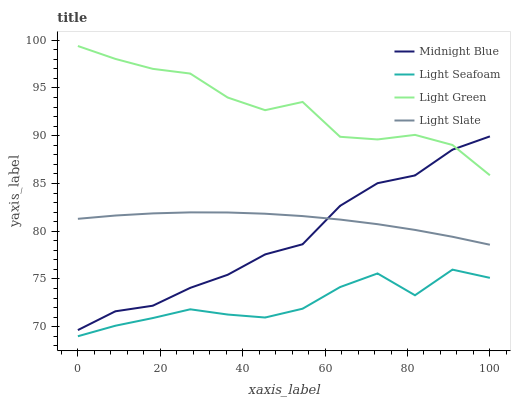Does Light Seafoam have the minimum area under the curve?
Answer yes or no. Yes. Does Light Green have the maximum area under the curve?
Answer yes or no. Yes. Does Midnight Blue have the minimum area under the curve?
Answer yes or no. No. Does Midnight Blue have the maximum area under the curve?
Answer yes or no. No. Is Light Slate the smoothest?
Answer yes or no. Yes. Is Light Green the roughest?
Answer yes or no. Yes. Is Light Seafoam the smoothest?
Answer yes or no. No. Is Light Seafoam the roughest?
Answer yes or no. No. Does Midnight Blue have the lowest value?
Answer yes or no. No. Does Light Green have the highest value?
Answer yes or no. Yes. Does Midnight Blue have the highest value?
Answer yes or no. No. Is Light Seafoam less than Light Slate?
Answer yes or no. Yes. Is Light Green greater than Light Seafoam?
Answer yes or no. Yes. Does Midnight Blue intersect Light Slate?
Answer yes or no. Yes. Is Midnight Blue less than Light Slate?
Answer yes or no. No. Is Midnight Blue greater than Light Slate?
Answer yes or no. No. Does Light Seafoam intersect Light Slate?
Answer yes or no. No. 